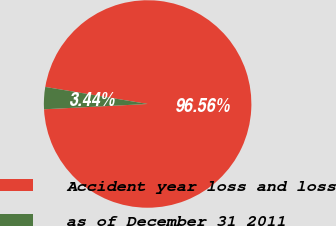Convert chart to OTSL. <chart><loc_0><loc_0><loc_500><loc_500><pie_chart><fcel>Accident year loss and loss<fcel>as of December 31 2011<nl><fcel>96.56%<fcel>3.44%<nl></chart> 